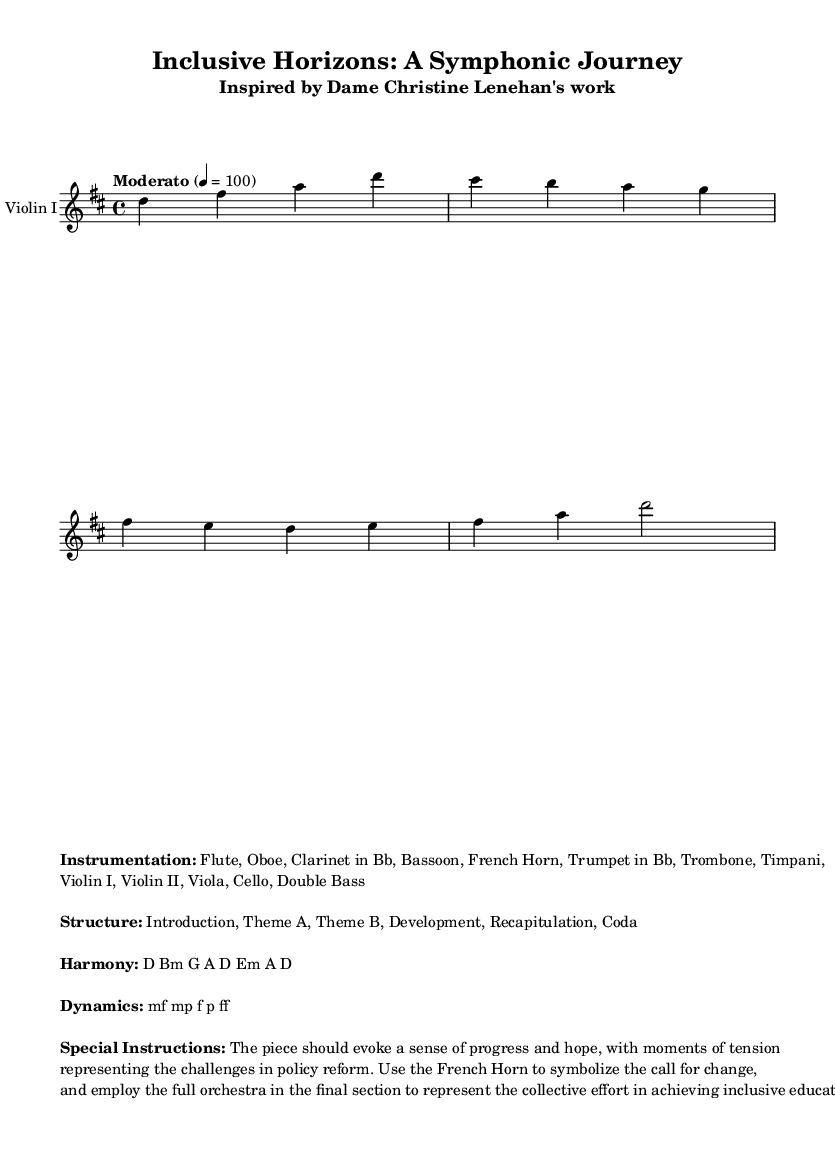What is the key signature of this music? The key signature is D major, which is indicated by the presence of two sharps (F# and C#).
Answer: D major What is the time signature of this music? The time signature is 4/4, as indicated at the beginning of the score, which means there are four beats per measure.
Answer: 4/4 What is the tempo marking of this piece? The tempo marking indicates "Moderato" at a speed of 100 beats per minute, which gives the piece a moderate pace.
Answer: Moderato 4 = 100 What are the main instrument sections used in this symphony? The main instrument sections include Woodwinds, Brass, Percussion, and Strings, as enumerated in the instrumentation section.
Answer: Flute, Oboe, Clarinet in Bb, Bassoon, French Horn, Trumpet in Bb, Trombone, Timpani, Violin I, Violin II, Viola, Cello, Double Bass Identify the structural sections of the symphony. The structure of the symphony is clearly outlined as "Introduction, Theme A, Theme B, Development, Recapitulation, Coda," which reflects traditional symphonic form.
Answer: Introduction, Theme A, Theme B, Development, Recapitulation, Coda Which instrument symbolizes the call for change in this piece? The French Horn is specifically mentioned in the special instructions to symbolize the call for change, representing the advocacy for policy reform.
Answer: French Horn What harmonic progression is used in this piece? The harmonic progression presented in the music is described as D Bm G A D Em A D, which specifies the chords through which the music will transition.
Answer: D Bm G A D Em A D 